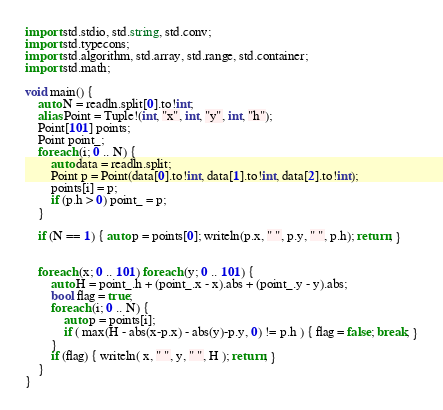Convert code to text. <code><loc_0><loc_0><loc_500><loc_500><_D_>import std.stdio, std.string, std.conv;
import std.typecons;
import std.algorithm, std.array, std.range, std.container;
import std.math;

void main() {
	auto N = readln.split[0].to!int;
	alias Point = Tuple!(int, "x", int, "y", int, "h");
	Point[101] points;
	Point point_;
	foreach (i; 0 .. N) {
		auto data = readln.split;
		Point p = Point(data[0].to!int, data[1].to!int, data[2].to!int);
		points[i] = p;
		if (p.h > 0) point_ = p;
	}
	
	if (N == 1) { auto p = points[0]; writeln(p.x, " ", p.y, " ", p.h); return; }
	

	foreach (x; 0 .. 101) foreach (y; 0 .. 101) {
		auto H = point_.h + (point_.x - x).abs + (point_.y - y).abs;
		bool flag = true;
		foreach (i; 0 .. N) {
			auto p = points[i];
			if ( max(H - abs(x-p.x) - abs(y)-p.y, 0) != p.h ) { flag = false; break; }
		}
		if (flag) { writeln( x, " ", y, " ", H ); return; }
	}
}</code> 